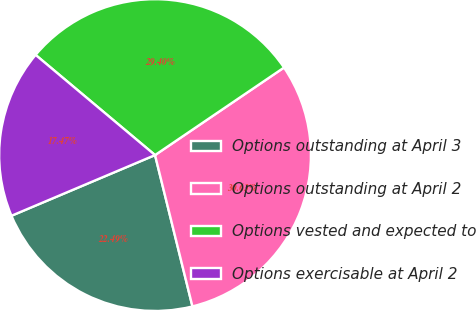<chart> <loc_0><loc_0><loc_500><loc_500><pie_chart><fcel>Options outstanding at April 3<fcel>Options outstanding at April 2<fcel>Options vested and expected to<fcel>Options exercisable at April 2<nl><fcel>22.49%<fcel>30.63%<fcel>29.4%<fcel>17.47%<nl></chart> 